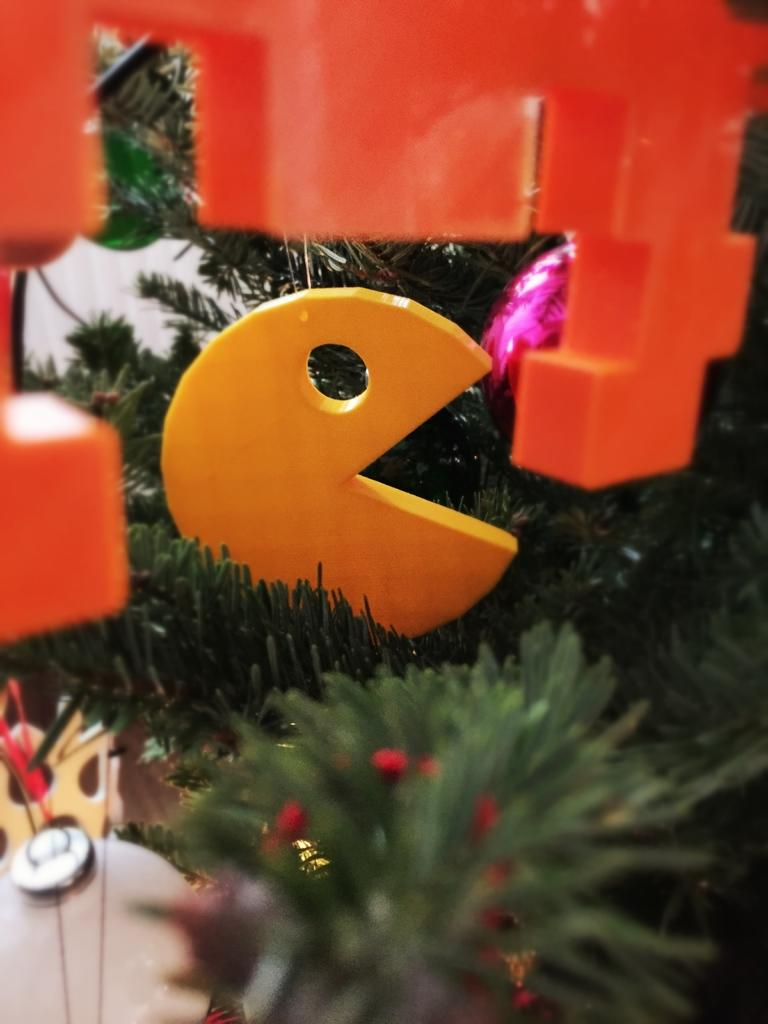What types of objects can be seen in the image? There are plants and toys in the image. Can you describe the plants in the image? Unfortunately, the facts provided do not give specific details about the plants. What kind of toys are present in the image? The facts provided do not specify the type of toys in the image. How many clocks are hanging on the wall in the image? There is no mention of clocks in the image, as the facts provided only mention plants and toys. What type of story is being told by the zebra in the image? There is no zebra present in the image, so no story can be told by a zebra. 